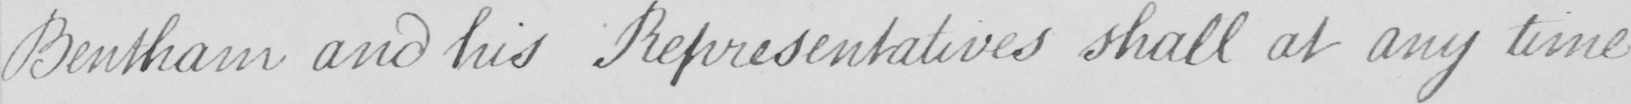What text is written in this handwritten line? Bentham and his Representatives shall at any time 